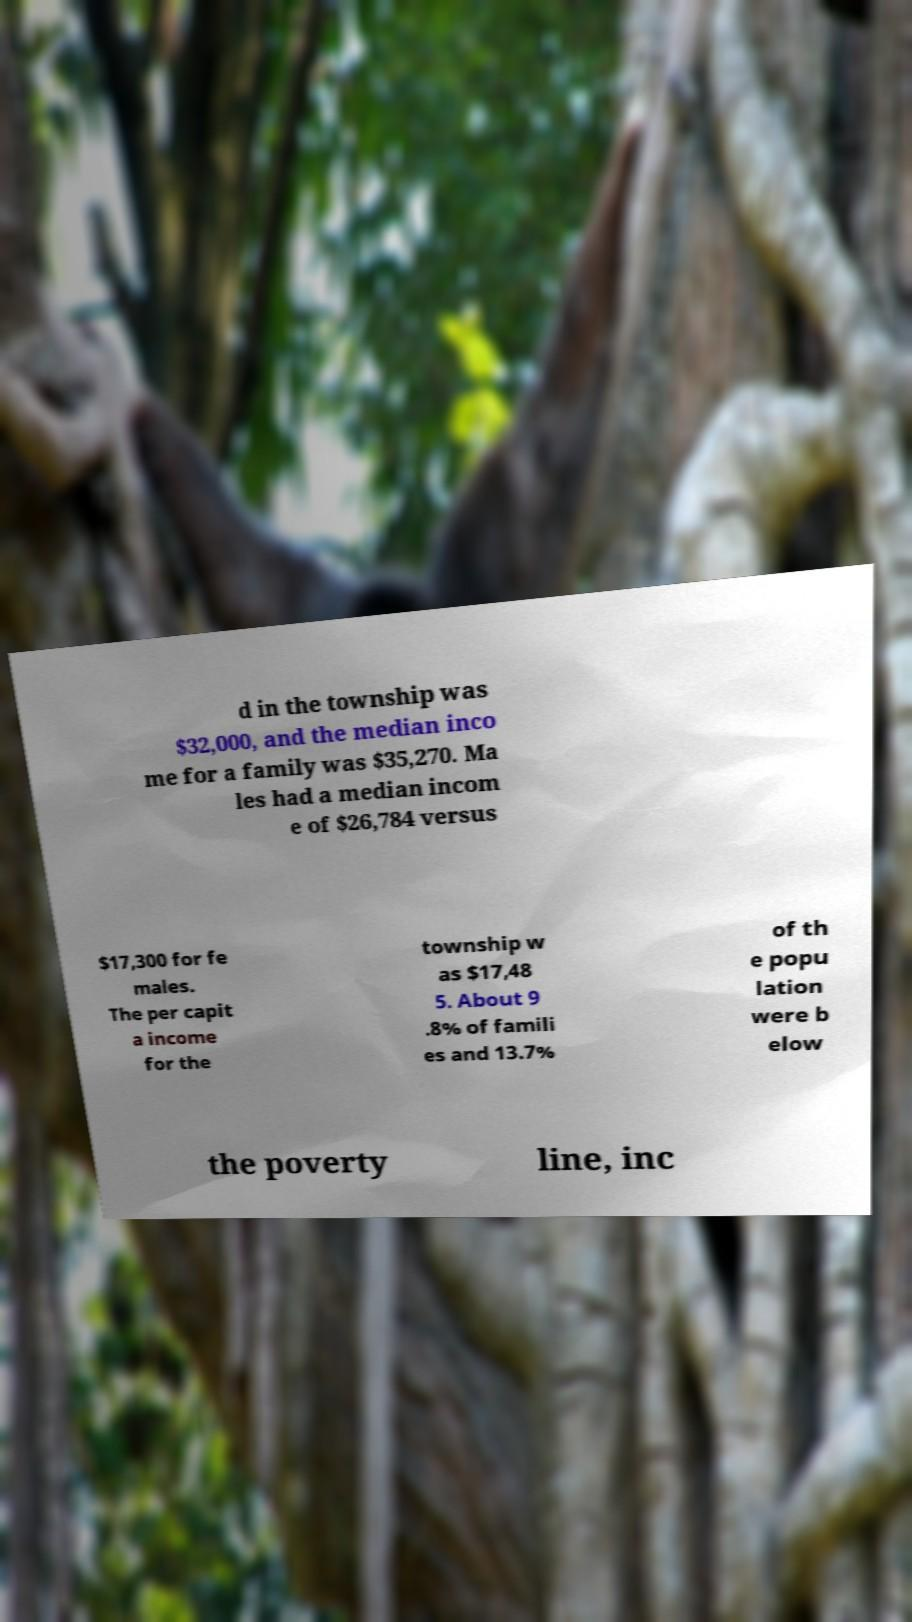There's text embedded in this image that I need extracted. Can you transcribe it verbatim? d in the township was $32,000, and the median inco me for a family was $35,270. Ma les had a median incom e of $26,784 versus $17,300 for fe males. The per capit a income for the township w as $17,48 5. About 9 .8% of famili es and 13.7% of th e popu lation were b elow the poverty line, inc 